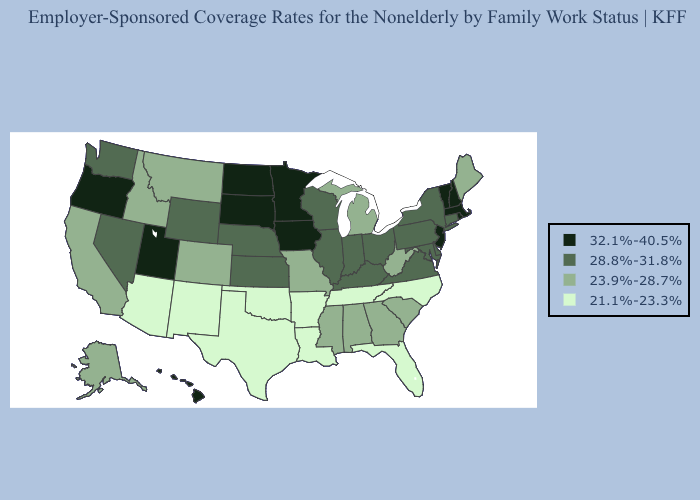What is the value of Minnesota?
Write a very short answer. 32.1%-40.5%. Among the states that border Georgia , which have the highest value?
Quick response, please. Alabama, South Carolina. What is the value of Oklahoma?
Quick response, please. 21.1%-23.3%. Does Kentucky have a lower value than Montana?
Answer briefly. No. Which states hav the highest value in the West?
Quick response, please. Hawaii, Oregon, Utah. What is the lowest value in the West?
Answer briefly. 21.1%-23.3%. Does North Carolina have the lowest value in the South?
Give a very brief answer. Yes. Does Minnesota have the lowest value in the USA?
Keep it brief. No. What is the highest value in the USA?
Quick response, please. 32.1%-40.5%. Name the states that have a value in the range 21.1%-23.3%?
Give a very brief answer. Arizona, Arkansas, Florida, Louisiana, New Mexico, North Carolina, Oklahoma, Tennessee, Texas. What is the value of Virginia?
Write a very short answer. 28.8%-31.8%. Does Michigan have the lowest value in the MidWest?
Concise answer only. Yes. What is the value of New York?
Keep it brief. 28.8%-31.8%. What is the highest value in states that border Pennsylvania?
Keep it brief. 32.1%-40.5%. Does the first symbol in the legend represent the smallest category?
Concise answer only. No. 